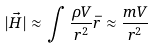Convert formula to latex. <formula><loc_0><loc_0><loc_500><loc_500>| \vec { H } | \approx \int \frac { \rho V } { r ^ { 2 } } \bar { r } \approx \frac { m V } { r ^ { 2 } }</formula> 